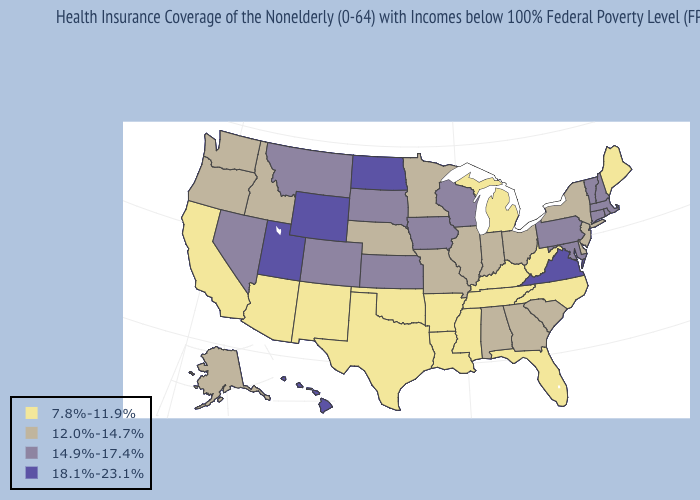Does California have the same value as Oregon?
Answer briefly. No. What is the value of Montana?
Keep it brief. 14.9%-17.4%. Name the states that have a value in the range 7.8%-11.9%?
Answer briefly. Arizona, Arkansas, California, Florida, Kentucky, Louisiana, Maine, Michigan, Mississippi, New Mexico, North Carolina, Oklahoma, Tennessee, Texas, West Virginia. Does South Carolina have the same value as New Hampshire?
Quick response, please. No. What is the value of Illinois?
Quick response, please. 12.0%-14.7%. What is the value of New Mexico?
Give a very brief answer. 7.8%-11.9%. What is the value of Oklahoma?
Concise answer only. 7.8%-11.9%. Does Pennsylvania have the lowest value in the USA?
Be succinct. No. Does North Dakota have the same value as New Jersey?
Be succinct. No. Does Maine have a lower value than Pennsylvania?
Write a very short answer. Yes. How many symbols are there in the legend?
Write a very short answer. 4. Does the map have missing data?
Be succinct. No. Does Delaware have the highest value in the USA?
Be succinct. No. 